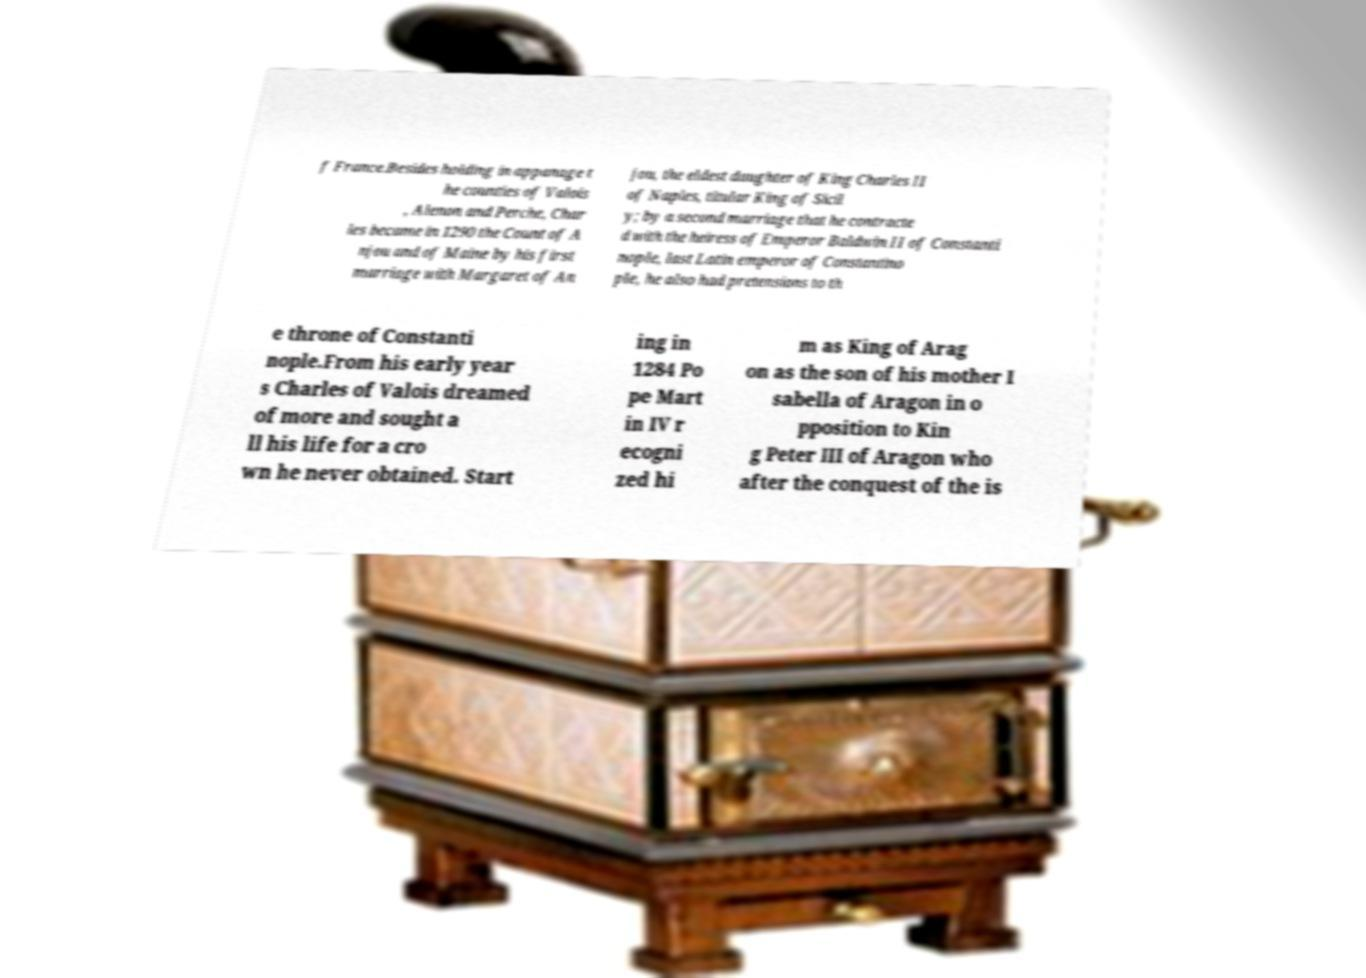Can you read and provide the text displayed in the image?This photo seems to have some interesting text. Can you extract and type it out for me? f France.Besides holding in appanage t he counties of Valois , Alenon and Perche, Char les became in 1290 the Count of A njou and of Maine by his first marriage with Margaret of An jou, the eldest daughter of King Charles II of Naples, titular King of Sicil y; by a second marriage that he contracte d with the heiress of Emperor Baldwin II of Constanti nople, last Latin emperor of Constantino ple, he also had pretensions to th e throne of Constanti nople.From his early year s Charles of Valois dreamed of more and sought a ll his life for a cro wn he never obtained. Start ing in 1284 Po pe Mart in IV r ecogni zed hi m as King of Arag on as the son of his mother I sabella of Aragon in o pposition to Kin g Peter III of Aragon who after the conquest of the is 